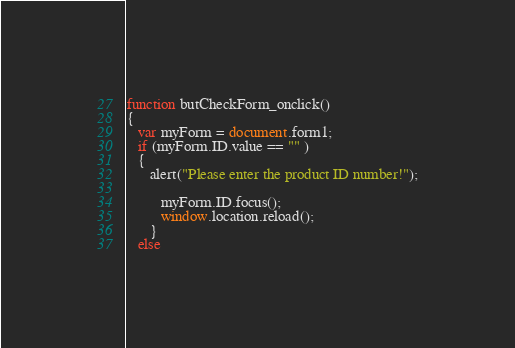Convert code to text. <code><loc_0><loc_0><loc_500><loc_500><_JavaScript_>function butCheckForm_onclick()
{
   var myForm = document.form1;
   if (myForm.ID.value == "" )
   {
      alert("Please enter the product ID number!");
      
         myForm.ID.focus();
         window.location.reload();
      }
   else</code> 